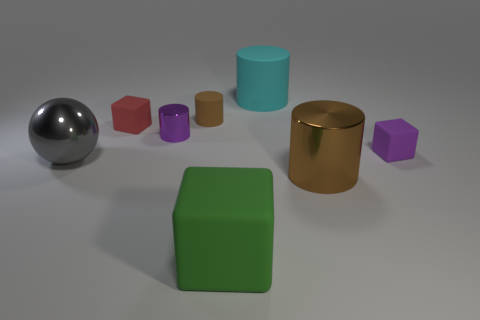Subtract all gray cylinders. Subtract all gray cubes. How many cylinders are left? 4 Add 2 green metallic cylinders. How many objects exist? 10 Subtract all balls. How many objects are left? 7 Add 3 metal objects. How many metal objects exist? 6 Subtract 0 green cylinders. How many objects are left? 8 Subtract all purple cylinders. Subtract all purple cylinders. How many objects are left? 6 Add 1 big spheres. How many big spheres are left? 2 